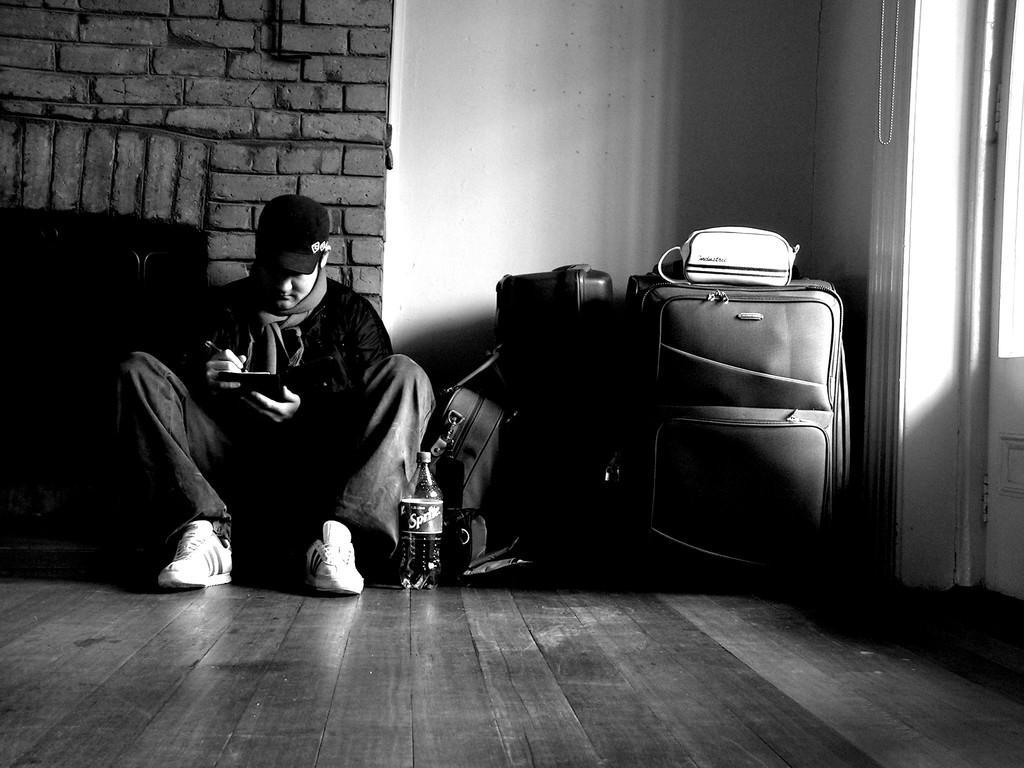Could you give a brief overview of what you see in this image? In this picture we can see a man is seated on the ground in front of him we can find a bottle and some baggage, in the background we can see a wall. 